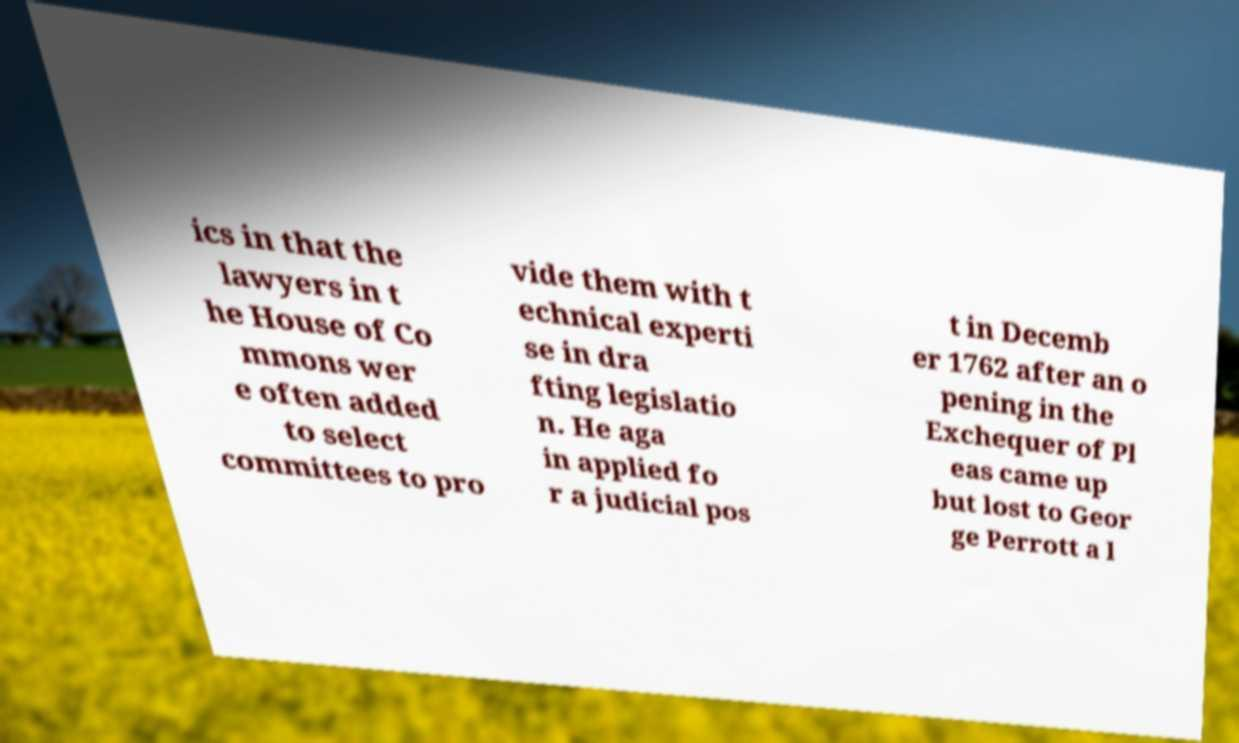Please identify and transcribe the text found in this image. ics in that the lawyers in t he House of Co mmons wer e often added to select committees to pro vide them with t echnical experti se in dra fting legislatio n. He aga in applied fo r a judicial pos t in Decemb er 1762 after an o pening in the Exchequer of Pl eas came up but lost to Geor ge Perrott a l 